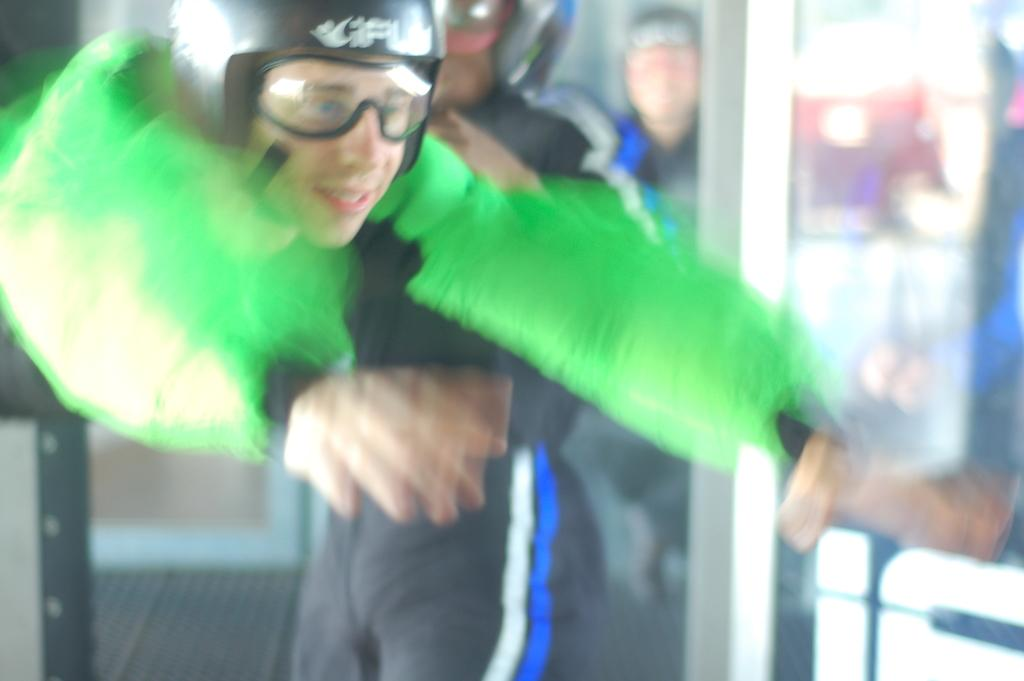What is the person in the image doing? The person in the image is jumping. What is the person wearing on their upper body? The person is wearing a green jacket. What protective gear is the person wearing? The person is wearing a helmet. What type of eyewear is the person wearing? The person is wearing glasses. Can you describe the people in the background of the image? The people in the background are wearing black dresses and helmets. What type of pot can be seen in the image? There is no pot present in the image. How many cherries are visible on the person's helmet? There are no cherries visible on the person's helmet or anywhere else in the image. 